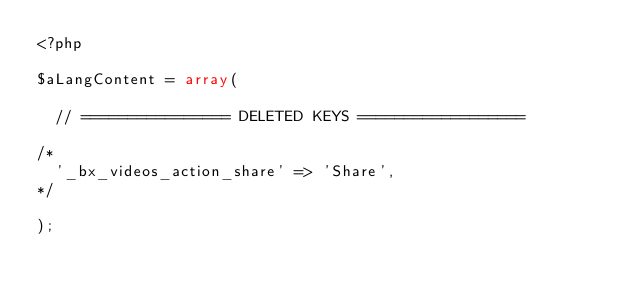<code> <loc_0><loc_0><loc_500><loc_500><_PHP_><?php

$aLangContent = array(

  // ================ DELETED KEYS ==================

/*
  '_bx_videos_action_share' => 'Share',
*/

);
</code> 